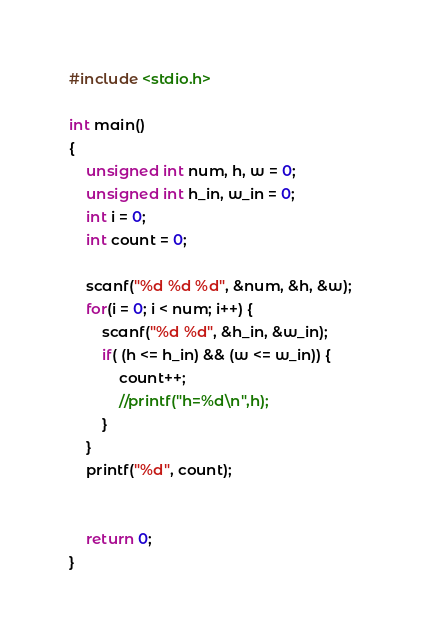Convert code to text. <code><loc_0><loc_0><loc_500><loc_500><_C_>#include <stdio.h>

int main()
{
	unsigned int num, h, w = 0;
	unsigned int h_in, w_in = 0;
	int i = 0;
	int count = 0;

	scanf("%d %d %d", &num, &h, &w);
    for(i = 0; i < num; i++) {
    	scanf("%d %d", &h_in, &w_in);
    	if( (h <= h_in) && (w <= w_in)) {
    		count++;
    		//printf("h=%d\n",h);
    	}
    }
    printf("%d", count);


	return 0;
}
</code> 